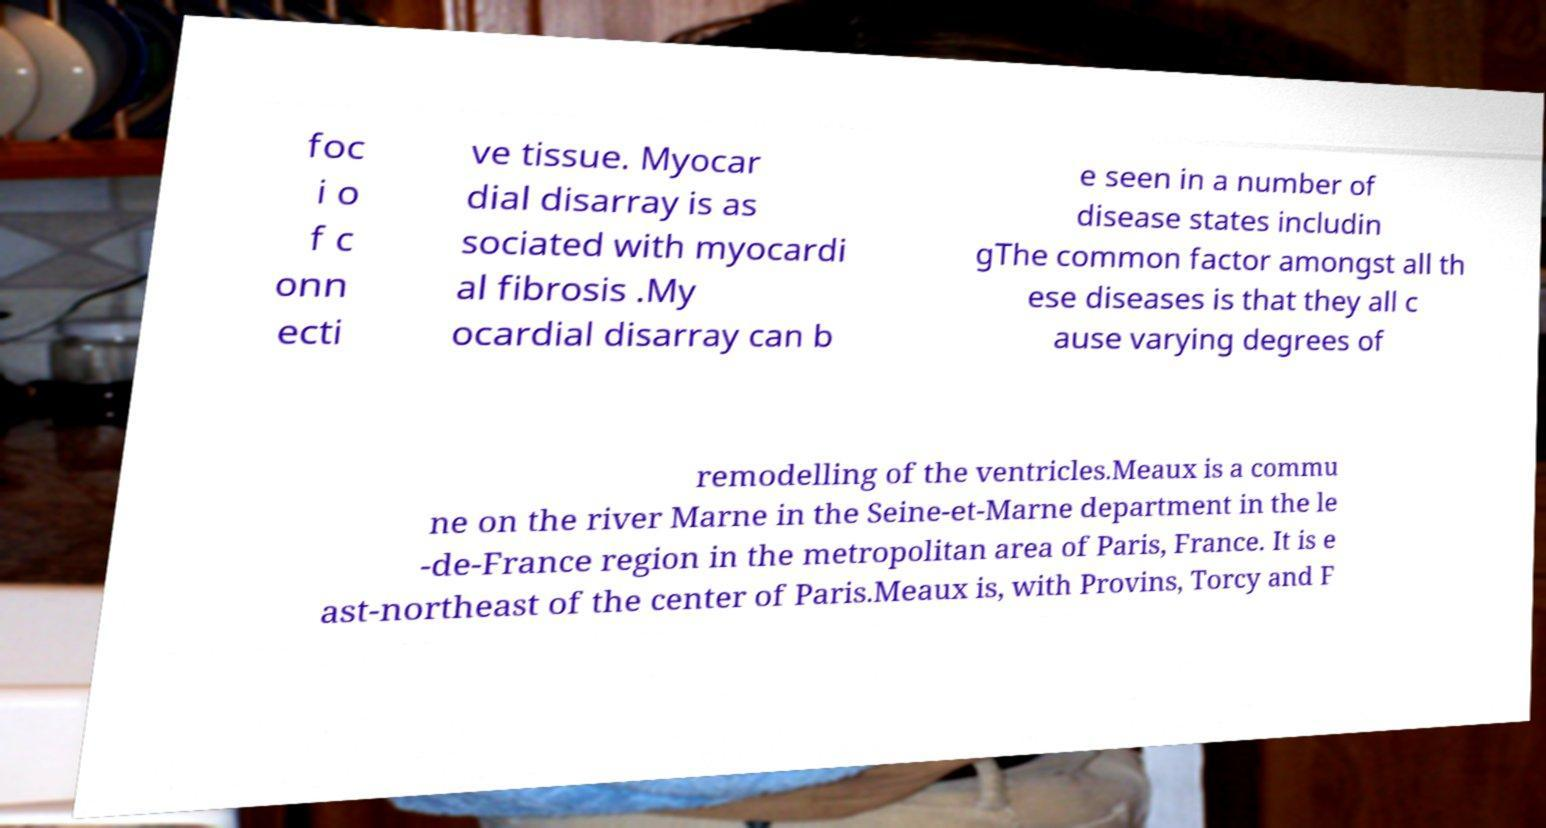What messages or text are displayed in this image? I need them in a readable, typed format. foc i o f c onn ecti ve tissue. Myocar dial disarray is as sociated with myocardi al fibrosis .My ocardial disarray can b e seen in a number of disease states includin gThe common factor amongst all th ese diseases is that they all c ause varying degrees of remodelling of the ventricles.Meaux is a commu ne on the river Marne in the Seine-et-Marne department in the le -de-France region in the metropolitan area of Paris, France. It is e ast-northeast of the center of Paris.Meaux is, with Provins, Torcy and F 